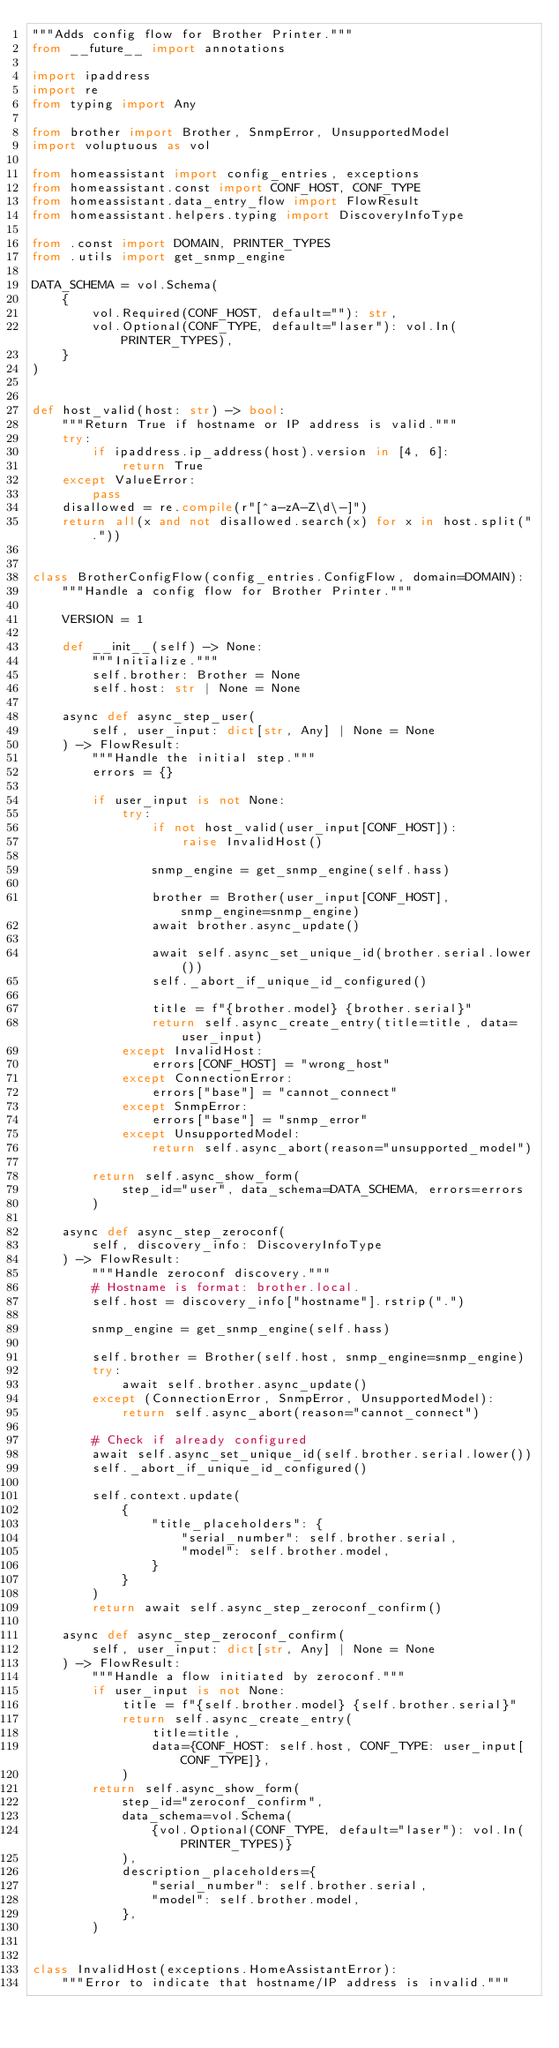Convert code to text. <code><loc_0><loc_0><loc_500><loc_500><_Python_>"""Adds config flow for Brother Printer."""
from __future__ import annotations

import ipaddress
import re
from typing import Any

from brother import Brother, SnmpError, UnsupportedModel
import voluptuous as vol

from homeassistant import config_entries, exceptions
from homeassistant.const import CONF_HOST, CONF_TYPE
from homeassistant.data_entry_flow import FlowResult
from homeassistant.helpers.typing import DiscoveryInfoType

from .const import DOMAIN, PRINTER_TYPES
from .utils import get_snmp_engine

DATA_SCHEMA = vol.Schema(
    {
        vol.Required(CONF_HOST, default=""): str,
        vol.Optional(CONF_TYPE, default="laser"): vol.In(PRINTER_TYPES),
    }
)


def host_valid(host: str) -> bool:
    """Return True if hostname or IP address is valid."""
    try:
        if ipaddress.ip_address(host).version in [4, 6]:
            return True
    except ValueError:
        pass
    disallowed = re.compile(r"[^a-zA-Z\d\-]")
    return all(x and not disallowed.search(x) for x in host.split("."))


class BrotherConfigFlow(config_entries.ConfigFlow, domain=DOMAIN):
    """Handle a config flow for Brother Printer."""

    VERSION = 1

    def __init__(self) -> None:
        """Initialize."""
        self.brother: Brother = None
        self.host: str | None = None

    async def async_step_user(
        self, user_input: dict[str, Any] | None = None
    ) -> FlowResult:
        """Handle the initial step."""
        errors = {}

        if user_input is not None:
            try:
                if not host_valid(user_input[CONF_HOST]):
                    raise InvalidHost()

                snmp_engine = get_snmp_engine(self.hass)

                brother = Brother(user_input[CONF_HOST], snmp_engine=snmp_engine)
                await brother.async_update()

                await self.async_set_unique_id(brother.serial.lower())
                self._abort_if_unique_id_configured()

                title = f"{brother.model} {brother.serial}"
                return self.async_create_entry(title=title, data=user_input)
            except InvalidHost:
                errors[CONF_HOST] = "wrong_host"
            except ConnectionError:
                errors["base"] = "cannot_connect"
            except SnmpError:
                errors["base"] = "snmp_error"
            except UnsupportedModel:
                return self.async_abort(reason="unsupported_model")

        return self.async_show_form(
            step_id="user", data_schema=DATA_SCHEMA, errors=errors
        )

    async def async_step_zeroconf(
        self, discovery_info: DiscoveryInfoType
    ) -> FlowResult:
        """Handle zeroconf discovery."""
        # Hostname is format: brother.local.
        self.host = discovery_info["hostname"].rstrip(".")

        snmp_engine = get_snmp_engine(self.hass)

        self.brother = Brother(self.host, snmp_engine=snmp_engine)
        try:
            await self.brother.async_update()
        except (ConnectionError, SnmpError, UnsupportedModel):
            return self.async_abort(reason="cannot_connect")

        # Check if already configured
        await self.async_set_unique_id(self.brother.serial.lower())
        self._abort_if_unique_id_configured()

        self.context.update(
            {
                "title_placeholders": {
                    "serial_number": self.brother.serial,
                    "model": self.brother.model,
                }
            }
        )
        return await self.async_step_zeroconf_confirm()

    async def async_step_zeroconf_confirm(
        self, user_input: dict[str, Any] | None = None
    ) -> FlowResult:
        """Handle a flow initiated by zeroconf."""
        if user_input is not None:
            title = f"{self.brother.model} {self.brother.serial}"
            return self.async_create_entry(
                title=title,
                data={CONF_HOST: self.host, CONF_TYPE: user_input[CONF_TYPE]},
            )
        return self.async_show_form(
            step_id="zeroconf_confirm",
            data_schema=vol.Schema(
                {vol.Optional(CONF_TYPE, default="laser"): vol.In(PRINTER_TYPES)}
            ),
            description_placeholders={
                "serial_number": self.brother.serial,
                "model": self.brother.model,
            },
        )


class InvalidHost(exceptions.HomeAssistantError):
    """Error to indicate that hostname/IP address is invalid."""
</code> 